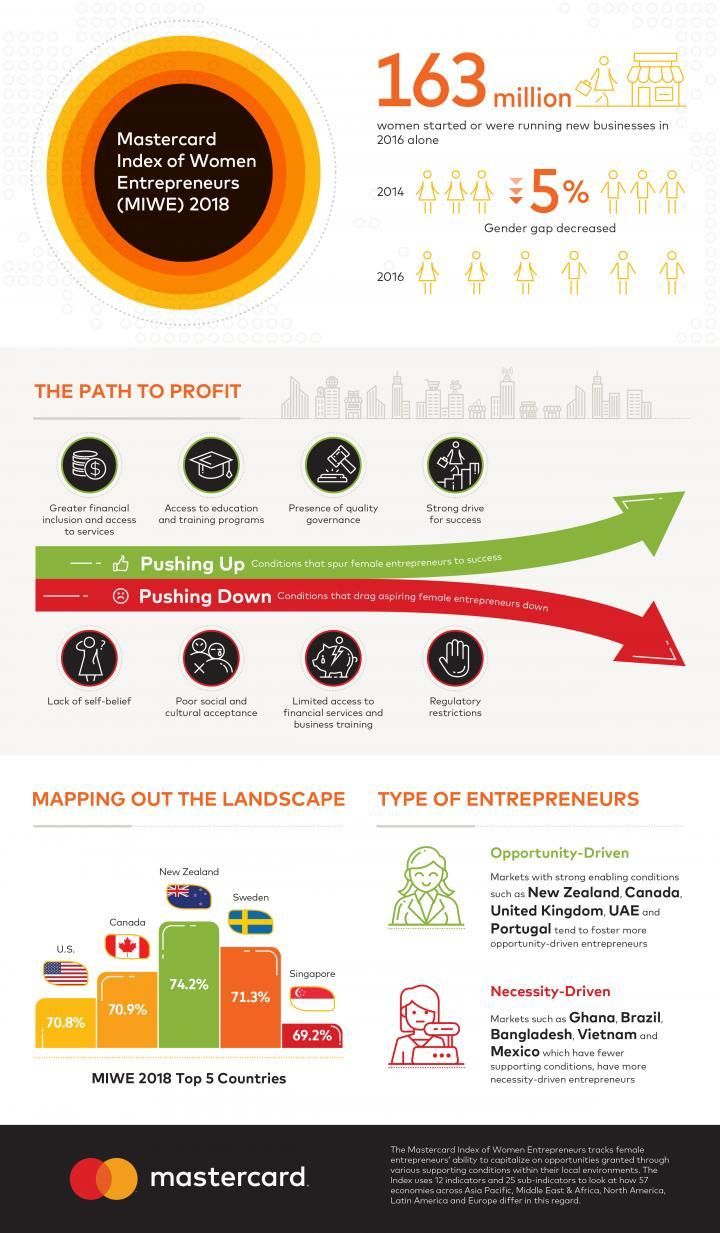Which country has the second-highest percent of women entrepreneurs among the top countries according to MIWE 2018?
Answer the question with a short phrase. Sweden What percent of women entrepreneurs are in Canada according to the MIWE 2018? 70.9% What are the two types of entrepreneurs? Opportunity-Driven, Necessity-Driven Which country has the highest percent of women entrepreneurs among the top countries according to MIWE 2018? New Zealand 